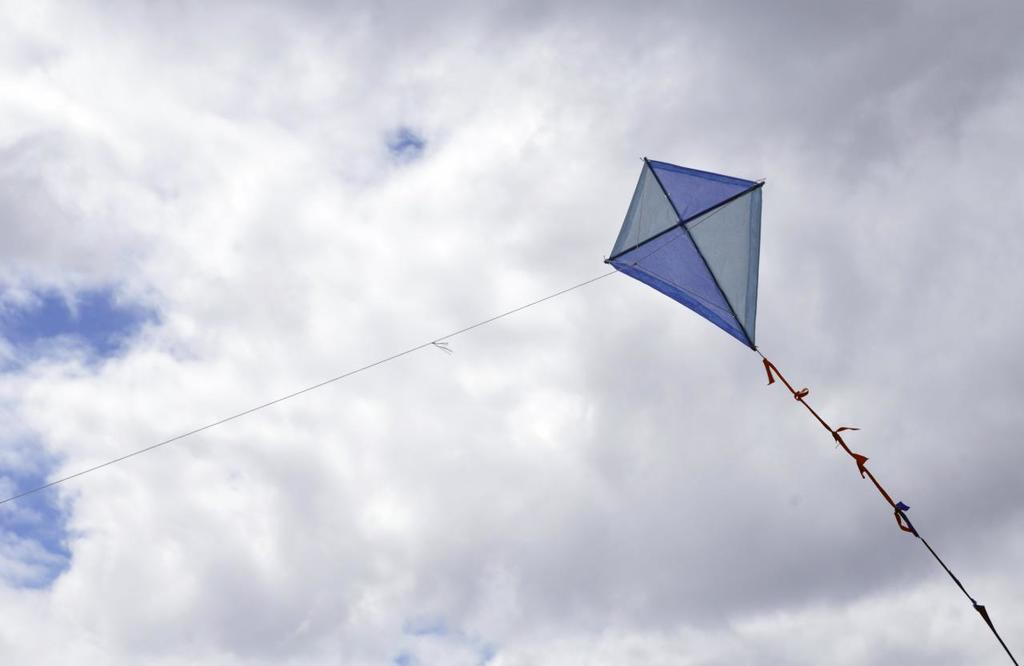What is the main subject of the image? The main subject of the image is a kite flying. Where is the kite located in the image? The kite is on the right side of the image. What is connected to the kite? There is a thread associated with the kite. What is visible at the top of the image? The sky is visible at the top of the image. What type of meat is being displayed on the desk in the image? There is no desk or meat present in the image; it features a kite flying in the sky. 